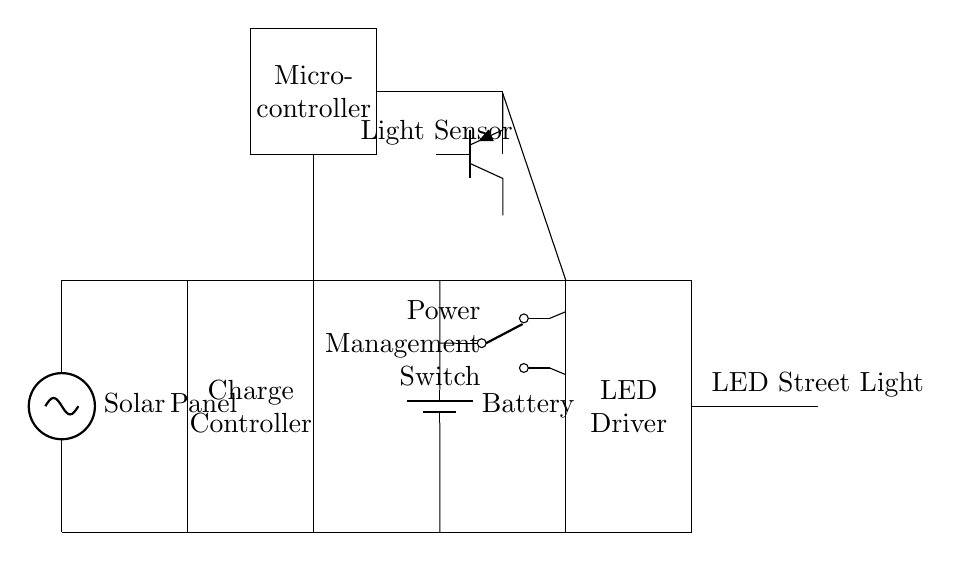What is the primary energy source for this circuit? The primary energy source is the solar panel, which converts sunlight into electrical energy.
Answer: Solar Panel What component stores energy generated by the solar panel? The component that stores energy is the battery, which is charged by the solar energy and provides backup power when needed.
Answer: Battery What controls the charging process of the battery? The charge controller controls the charging process by managing the voltage and current coming from the solar panel to protect the battery from overcharging.
Answer: Charge Controller What is the function of the light sensor in this circuit? The light sensor detects ambient light levels and signals the microcontroller to turn the LED street light on or off based on the available light, optimizing energy usage.
Answer: Light Sensor What type of switch is used for power management in this circuit? The circuit employs a power management switch that can route power either from the solar panel or the battery to the LED driver, depending on the conditions.
Answer: Power Management Switch How does the microcontroller interact with the LED driver? The microcontroller sends control signals to the LED driver to regulate the operation of the LED street light based on inputs from the light sensor.
Answer: Regulate Operation 